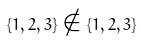Convert formula to latex. <formula><loc_0><loc_0><loc_500><loc_500>\{ 1 , 2 , 3 \} \notin \{ 1 , 2 , 3 \}</formula> 